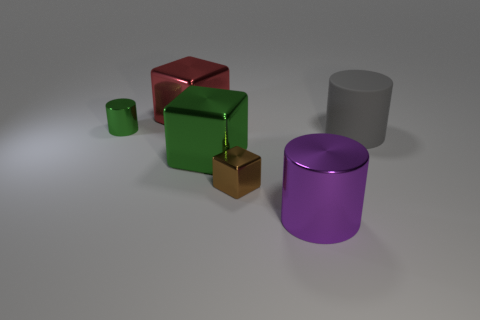What number of purple things are either small cylinders or big cylinders?
Your answer should be very brief. 1. What number of metal blocks are the same color as the tiny metallic cylinder?
Offer a very short reply. 1. Is there anything else that has the same shape as the red thing?
Give a very brief answer. Yes. How many balls are either big purple metal things or big brown things?
Give a very brief answer. 0. What color is the cube that is behind the tiny cylinder?
Make the answer very short. Red. What shape is the thing that is the same size as the green cylinder?
Your response must be concise. Cube. What number of gray matte objects are to the left of the green cylinder?
Your response must be concise. 0. How many things are brown matte cylinders or big objects?
Your response must be concise. 4. The big metal object that is both to the right of the red metallic block and left of the large metal cylinder has what shape?
Ensure brevity in your answer.  Cube. How many small cyan rubber balls are there?
Your response must be concise. 0. 